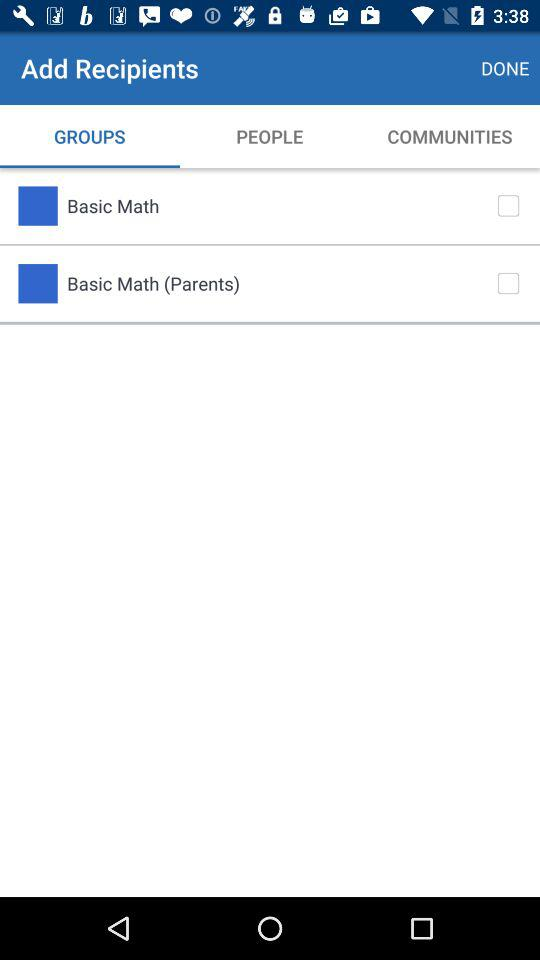What is the name of the application?
When the provided information is insufficient, respond with <no answer>. <no answer> 